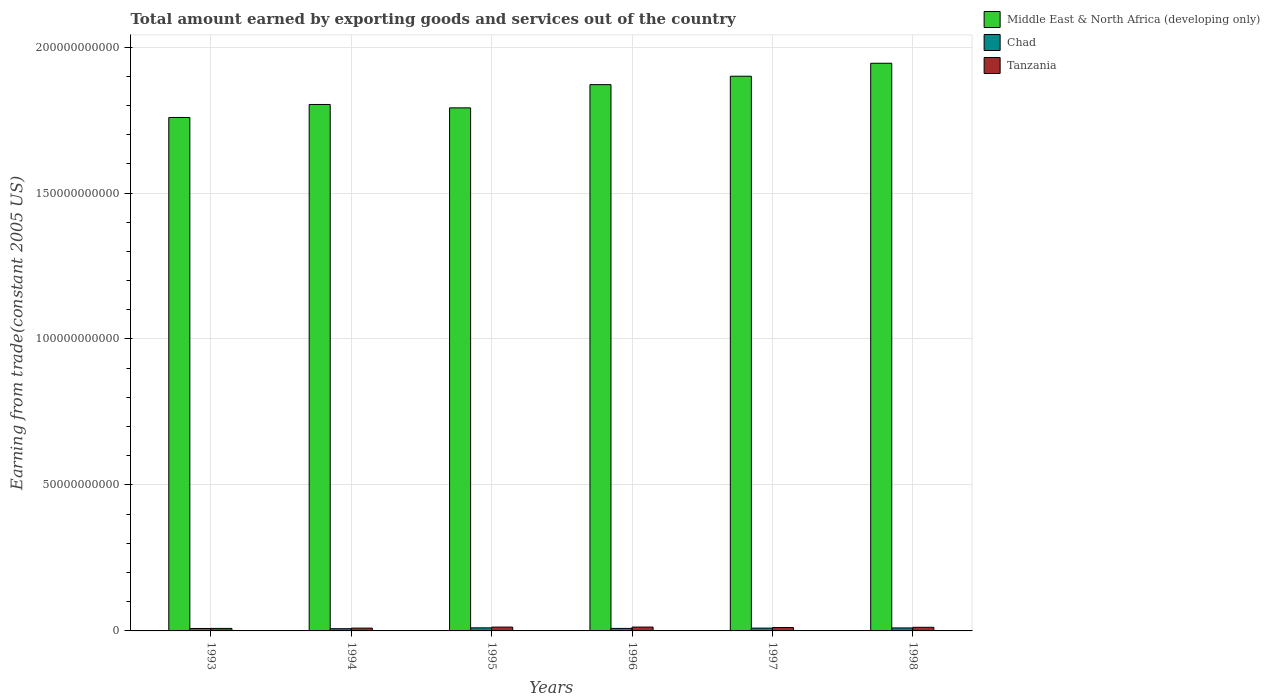Are the number of bars per tick equal to the number of legend labels?
Provide a short and direct response. Yes. How many bars are there on the 6th tick from the left?
Provide a short and direct response. 3. What is the label of the 2nd group of bars from the left?
Your response must be concise. 1994. What is the total amount earned by exporting goods and services in Chad in 1994?
Keep it short and to the point. 7.63e+08. Across all years, what is the maximum total amount earned by exporting goods and services in Middle East & North Africa (developing only)?
Your answer should be very brief. 1.94e+11. Across all years, what is the minimum total amount earned by exporting goods and services in Middle East & North Africa (developing only)?
Keep it short and to the point. 1.76e+11. What is the total total amount earned by exporting goods and services in Middle East & North Africa (developing only) in the graph?
Your answer should be very brief. 1.11e+12. What is the difference between the total amount earned by exporting goods and services in Middle East & North Africa (developing only) in 1996 and that in 1997?
Keep it short and to the point. -2.87e+09. What is the difference between the total amount earned by exporting goods and services in Tanzania in 1994 and the total amount earned by exporting goods and services in Chad in 1995?
Offer a very short reply. -9.25e+07. What is the average total amount earned by exporting goods and services in Middle East & North Africa (developing only) per year?
Keep it short and to the point. 1.85e+11. In the year 1997, what is the difference between the total amount earned by exporting goods and services in Middle East & North Africa (developing only) and total amount earned by exporting goods and services in Chad?
Offer a terse response. 1.89e+11. In how many years, is the total amount earned by exporting goods and services in Tanzania greater than 100000000000 US$?
Your response must be concise. 0. What is the ratio of the total amount earned by exporting goods and services in Middle East & North Africa (developing only) in 1994 to that in 1996?
Your answer should be compact. 0.96. Is the total amount earned by exporting goods and services in Middle East & North Africa (developing only) in 1993 less than that in 1998?
Give a very brief answer. Yes. What is the difference between the highest and the second highest total amount earned by exporting goods and services in Tanzania?
Offer a terse response. 1.37e+07. What is the difference between the highest and the lowest total amount earned by exporting goods and services in Chad?
Your answer should be very brief. 2.89e+08. What does the 3rd bar from the left in 1993 represents?
Ensure brevity in your answer.  Tanzania. What does the 1st bar from the right in 1994 represents?
Ensure brevity in your answer.  Tanzania. How many years are there in the graph?
Provide a succinct answer. 6. What is the difference between two consecutive major ticks on the Y-axis?
Keep it short and to the point. 5.00e+1. Are the values on the major ticks of Y-axis written in scientific E-notation?
Provide a succinct answer. No. Where does the legend appear in the graph?
Give a very brief answer. Top right. How many legend labels are there?
Provide a succinct answer. 3. What is the title of the graph?
Give a very brief answer. Total amount earned by exporting goods and services out of the country. What is the label or title of the X-axis?
Your answer should be compact. Years. What is the label or title of the Y-axis?
Your response must be concise. Earning from trade(constant 2005 US). What is the Earning from trade(constant 2005 US) of Middle East & North Africa (developing only) in 1993?
Your response must be concise. 1.76e+11. What is the Earning from trade(constant 2005 US) in Chad in 1993?
Offer a terse response. 8.40e+08. What is the Earning from trade(constant 2005 US) in Tanzania in 1993?
Provide a succinct answer. 8.60e+08. What is the Earning from trade(constant 2005 US) in Middle East & North Africa (developing only) in 1994?
Your response must be concise. 1.80e+11. What is the Earning from trade(constant 2005 US) in Chad in 1994?
Offer a terse response. 7.63e+08. What is the Earning from trade(constant 2005 US) of Tanzania in 1994?
Offer a terse response. 9.59e+08. What is the Earning from trade(constant 2005 US) of Middle East & North Africa (developing only) in 1995?
Ensure brevity in your answer.  1.79e+11. What is the Earning from trade(constant 2005 US) in Chad in 1995?
Your response must be concise. 1.05e+09. What is the Earning from trade(constant 2005 US) in Tanzania in 1995?
Give a very brief answer. 1.31e+09. What is the Earning from trade(constant 2005 US) in Middle East & North Africa (developing only) in 1996?
Make the answer very short. 1.87e+11. What is the Earning from trade(constant 2005 US) of Chad in 1996?
Your answer should be compact. 8.60e+08. What is the Earning from trade(constant 2005 US) in Tanzania in 1996?
Ensure brevity in your answer.  1.32e+09. What is the Earning from trade(constant 2005 US) of Middle East & North Africa (developing only) in 1997?
Provide a short and direct response. 1.90e+11. What is the Earning from trade(constant 2005 US) of Chad in 1997?
Your response must be concise. 9.61e+08. What is the Earning from trade(constant 2005 US) of Tanzania in 1997?
Offer a very short reply. 1.16e+09. What is the Earning from trade(constant 2005 US) of Middle East & North Africa (developing only) in 1998?
Your response must be concise. 1.94e+11. What is the Earning from trade(constant 2005 US) of Chad in 1998?
Keep it short and to the point. 1.02e+09. What is the Earning from trade(constant 2005 US) in Tanzania in 1998?
Your answer should be compact. 1.24e+09. Across all years, what is the maximum Earning from trade(constant 2005 US) of Middle East & North Africa (developing only)?
Provide a succinct answer. 1.94e+11. Across all years, what is the maximum Earning from trade(constant 2005 US) in Chad?
Give a very brief answer. 1.05e+09. Across all years, what is the maximum Earning from trade(constant 2005 US) in Tanzania?
Your response must be concise. 1.32e+09. Across all years, what is the minimum Earning from trade(constant 2005 US) of Middle East & North Africa (developing only)?
Offer a very short reply. 1.76e+11. Across all years, what is the minimum Earning from trade(constant 2005 US) of Chad?
Your answer should be compact. 7.63e+08. Across all years, what is the minimum Earning from trade(constant 2005 US) of Tanzania?
Ensure brevity in your answer.  8.60e+08. What is the total Earning from trade(constant 2005 US) of Middle East & North Africa (developing only) in the graph?
Provide a short and direct response. 1.11e+12. What is the total Earning from trade(constant 2005 US) in Chad in the graph?
Give a very brief answer. 5.50e+09. What is the total Earning from trade(constant 2005 US) of Tanzania in the graph?
Your answer should be compact. 6.85e+09. What is the difference between the Earning from trade(constant 2005 US) in Middle East & North Africa (developing only) in 1993 and that in 1994?
Keep it short and to the point. -4.45e+09. What is the difference between the Earning from trade(constant 2005 US) in Chad in 1993 and that in 1994?
Provide a short and direct response. 7.65e+07. What is the difference between the Earning from trade(constant 2005 US) of Tanzania in 1993 and that in 1994?
Provide a short and direct response. -9.94e+07. What is the difference between the Earning from trade(constant 2005 US) of Middle East & North Africa (developing only) in 1993 and that in 1995?
Provide a succinct answer. -3.29e+09. What is the difference between the Earning from trade(constant 2005 US) in Chad in 1993 and that in 1995?
Provide a succinct answer. -2.12e+08. What is the difference between the Earning from trade(constant 2005 US) of Tanzania in 1993 and that in 1995?
Make the answer very short. -4.48e+08. What is the difference between the Earning from trade(constant 2005 US) of Middle East & North Africa (developing only) in 1993 and that in 1996?
Make the answer very short. -1.13e+1. What is the difference between the Earning from trade(constant 2005 US) of Chad in 1993 and that in 1996?
Offer a very short reply. -2.05e+07. What is the difference between the Earning from trade(constant 2005 US) in Tanzania in 1993 and that in 1996?
Provide a short and direct response. -4.62e+08. What is the difference between the Earning from trade(constant 2005 US) in Middle East & North Africa (developing only) in 1993 and that in 1997?
Offer a very short reply. -1.41e+1. What is the difference between the Earning from trade(constant 2005 US) of Chad in 1993 and that in 1997?
Make the answer very short. -1.21e+08. What is the difference between the Earning from trade(constant 2005 US) in Tanzania in 1993 and that in 1997?
Keep it short and to the point. -3.03e+08. What is the difference between the Earning from trade(constant 2005 US) in Middle East & North Africa (developing only) in 1993 and that in 1998?
Ensure brevity in your answer.  -1.86e+1. What is the difference between the Earning from trade(constant 2005 US) of Chad in 1993 and that in 1998?
Your answer should be very brief. -1.85e+08. What is the difference between the Earning from trade(constant 2005 US) of Tanzania in 1993 and that in 1998?
Your answer should be very brief. -3.79e+08. What is the difference between the Earning from trade(constant 2005 US) of Middle East & North Africa (developing only) in 1994 and that in 1995?
Your answer should be very brief. 1.16e+09. What is the difference between the Earning from trade(constant 2005 US) in Chad in 1994 and that in 1995?
Your answer should be very brief. -2.89e+08. What is the difference between the Earning from trade(constant 2005 US) of Tanzania in 1994 and that in 1995?
Ensure brevity in your answer.  -3.49e+08. What is the difference between the Earning from trade(constant 2005 US) in Middle East & North Africa (developing only) in 1994 and that in 1996?
Give a very brief answer. -6.81e+09. What is the difference between the Earning from trade(constant 2005 US) of Chad in 1994 and that in 1996?
Ensure brevity in your answer.  -9.70e+07. What is the difference between the Earning from trade(constant 2005 US) of Tanzania in 1994 and that in 1996?
Provide a succinct answer. -3.62e+08. What is the difference between the Earning from trade(constant 2005 US) in Middle East & North Africa (developing only) in 1994 and that in 1997?
Your answer should be compact. -9.68e+09. What is the difference between the Earning from trade(constant 2005 US) in Chad in 1994 and that in 1997?
Offer a very short reply. -1.97e+08. What is the difference between the Earning from trade(constant 2005 US) in Tanzania in 1994 and that in 1997?
Ensure brevity in your answer.  -2.04e+08. What is the difference between the Earning from trade(constant 2005 US) in Middle East & North Africa (developing only) in 1994 and that in 1998?
Offer a terse response. -1.41e+1. What is the difference between the Earning from trade(constant 2005 US) in Chad in 1994 and that in 1998?
Provide a succinct answer. -2.61e+08. What is the difference between the Earning from trade(constant 2005 US) in Tanzania in 1994 and that in 1998?
Keep it short and to the point. -2.79e+08. What is the difference between the Earning from trade(constant 2005 US) of Middle East & North Africa (developing only) in 1995 and that in 1996?
Your answer should be very brief. -7.96e+09. What is the difference between the Earning from trade(constant 2005 US) in Chad in 1995 and that in 1996?
Give a very brief answer. 1.92e+08. What is the difference between the Earning from trade(constant 2005 US) in Tanzania in 1995 and that in 1996?
Keep it short and to the point. -1.37e+07. What is the difference between the Earning from trade(constant 2005 US) in Middle East & North Africa (developing only) in 1995 and that in 1997?
Your answer should be compact. -1.08e+1. What is the difference between the Earning from trade(constant 2005 US) in Chad in 1995 and that in 1997?
Your answer should be compact. 9.13e+07. What is the difference between the Earning from trade(constant 2005 US) in Tanzania in 1995 and that in 1997?
Offer a very short reply. 1.45e+08. What is the difference between the Earning from trade(constant 2005 US) in Middle East & North Africa (developing only) in 1995 and that in 1998?
Offer a very short reply. -1.53e+1. What is the difference between the Earning from trade(constant 2005 US) in Chad in 1995 and that in 1998?
Provide a short and direct response. 2.74e+07. What is the difference between the Earning from trade(constant 2005 US) in Tanzania in 1995 and that in 1998?
Your response must be concise. 6.93e+07. What is the difference between the Earning from trade(constant 2005 US) in Middle East & North Africa (developing only) in 1996 and that in 1997?
Make the answer very short. -2.87e+09. What is the difference between the Earning from trade(constant 2005 US) of Chad in 1996 and that in 1997?
Your answer should be very brief. -1.00e+08. What is the difference between the Earning from trade(constant 2005 US) in Tanzania in 1996 and that in 1997?
Provide a short and direct response. 1.58e+08. What is the difference between the Earning from trade(constant 2005 US) of Middle East & North Africa (developing only) in 1996 and that in 1998?
Make the answer very short. -7.32e+09. What is the difference between the Earning from trade(constant 2005 US) in Chad in 1996 and that in 1998?
Give a very brief answer. -1.64e+08. What is the difference between the Earning from trade(constant 2005 US) of Tanzania in 1996 and that in 1998?
Make the answer very short. 8.30e+07. What is the difference between the Earning from trade(constant 2005 US) in Middle East & North Africa (developing only) in 1997 and that in 1998?
Give a very brief answer. -4.44e+09. What is the difference between the Earning from trade(constant 2005 US) of Chad in 1997 and that in 1998?
Your response must be concise. -6.39e+07. What is the difference between the Earning from trade(constant 2005 US) in Tanzania in 1997 and that in 1998?
Your response must be concise. -7.54e+07. What is the difference between the Earning from trade(constant 2005 US) in Middle East & North Africa (developing only) in 1993 and the Earning from trade(constant 2005 US) in Chad in 1994?
Give a very brief answer. 1.75e+11. What is the difference between the Earning from trade(constant 2005 US) in Middle East & North Africa (developing only) in 1993 and the Earning from trade(constant 2005 US) in Tanzania in 1994?
Provide a succinct answer. 1.75e+11. What is the difference between the Earning from trade(constant 2005 US) of Chad in 1993 and the Earning from trade(constant 2005 US) of Tanzania in 1994?
Your response must be concise. -1.20e+08. What is the difference between the Earning from trade(constant 2005 US) in Middle East & North Africa (developing only) in 1993 and the Earning from trade(constant 2005 US) in Chad in 1995?
Make the answer very short. 1.75e+11. What is the difference between the Earning from trade(constant 2005 US) of Middle East & North Africa (developing only) in 1993 and the Earning from trade(constant 2005 US) of Tanzania in 1995?
Give a very brief answer. 1.75e+11. What is the difference between the Earning from trade(constant 2005 US) of Chad in 1993 and the Earning from trade(constant 2005 US) of Tanzania in 1995?
Offer a terse response. -4.68e+08. What is the difference between the Earning from trade(constant 2005 US) in Middle East & North Africa (developing only) in 1993 and the Earning from trade(constant 2005 US) in Chad in 1996?
Ensure brevity in your answer.  1.75e+11. What is the difference between the Earning from trade(constant 2005 US) of Middle East & North Africa (developing only) in 1993 and the Earning from trade(constant 2005 US) of Tanzania in 1996?
Offer a terse response. 1.75e+11. What is the difference between the Earning from trade(constant 2005 US) of Chad in 1993 and the Earning from trade(constant 2005 US) of Tanzania in 1996?
Your answer should be very brief. -4.82e+08. What is the difference between the Earning from trade(constant 2005 US) in Middle East & North Africa (developing only) in 1993 and the Earning from trade(constant 2005 US) in Chad in 1997?
Make the answer very short. 1.75e+11. What is the difference between the Earning from trade(constant 2005 US) in Middle East & North Africa (developing only) in 1993 and the Earning from trade(constant 2005 US) in Tanzania in 1997?
Give a very brief answer. 1.75e+11. What is the difference between the Earning from trade(constant 2005 US) of Chad in 1993 and the Earning from trade(constant 2005 US) of Tanzania in 1997?
Keep it short and to the point. -3.24e+08. What is the difference between the Earning from trade(constant 2005 US) of Middle East & North Africa (developing only) in 1993 and the Earning from trade(constant 2005 US) of Chad in 1998?
Give a very brief answer. 1.75e+11. What is the difference between the Earning from trade(constant 2005 US) of Middle East & North Africa (developing only) in 1993 and the Earning from trade(constant 2005 US) of Tanzania in 1998?
Ensure brevity in your answer.  1.75e+11. What is the difference between the Earning from trade(constant 2005 US) in Chad in 1993 and the Earning from trade(constant 2005 US) in Tanzania in 1998?
Provide a succinct answer. -3.99e+08. What is the difference between the Earning from trade(constant 2005 US) of Middle East & North Africa (developing only) in 1994 and the Earning from trade(constant 2005 US) of Chad in 1995?
Ensure brevity in your answer.  1.79e+11. What is the difference between the Earning from trade(constant 2005 US) of Middle East & North Africa (developing only) in 1994 and the Earning from trade(constant 2005 US) of Tanzania in 1995?
Your answer should be compact. 1.79e+11. What is the difference between the Earning from trade(constant 2005 US) in Chad in 1994 and the Earning from trade(constant 2005 US) in Tanzania in 1995?
Provide a succinct answer. -5.45e+08. What is the difference between the Earning from trade(constant 2005 US) of Middle East & North Africa (developing only) in 1994 and the Earning from trade(constant 2005 US) of Chad in 1996?
Keep it short and to the point. 1.79e+11. What is the difference between the Earning from trade(constant 2005 US) in Middle East & North Africa (developing only) in 1994 and the Earning from trade(constant 2005 US) in Tanzania in 1996?
Offer a very short reply. 1.79e+11. What is the difference between the Earning from trade(constant 2005 US) in Chad in 1994 and the Earning from trade(constant 2005 US) in Tanzania in 1996?
Your response must be concise. -5.59e+08. What is the difference between the Earning from trade(constant 2005 US) in Middle East & North Africa (developing only) in 1994 and the Earning from trade(constant 2005 US) in Chad in 1997?
Make the answer very short. 1.79e+11. What is the difference between the Earning from trade(constant 2005 US) in Middle East & North Africa (developing only) in 1994 and the Earning from trade(constant 2005 US) in Tanzania in 1997?
Your response must be concise. 1.79e+11. What is the difference between the Earning from trade(constant 2005 US) of Chad in 1994 and the Earning from trade(constant 2005 US) of Tanzania in 1997?
Give a very brief answer. -4.00e+08. What is the difference between the Earning from trade(constant 2005 US) of Middle East & North Africa (developing only) in 1994 and the Earning from trade(constant 2005 US) of Chad in 1998?
Give a very brief answer. 1.79e+11. What is the difference between the Earning from trade(constant 2005 US) in Middle East & North Africa (developing only) in 1994 and the Earning from trade(constant 2005 US) in Tanzania in 1998?
Your answer should be very brief. 1.79e+11. What is the difference between the Earning from trade(constant 2005 US) in Chad in 1994 and the Earning from trade(constant 2005 US) in Tanzania in 1998?
Offer a terse response. -4.76e+08. What is the difference between the Earning from trade(constant 2005 US) of Middle East & North Africa (developing only) in 1995 and the Earning from trade(constant 2005 US) of Chad in 1996?
Your answer should be very brief. 1.78e+11. What is the difference between the Earning from trade(constant 2005 US) of Middle East & North Africa (developing only) in 1995 and the Earning from trade(constant 2005 US) of Tanzania in 1996?
Provide a short and direct response. 1.78e+11. What is the difference between the Earning from trade(constant 2005 US) of Chad in 1995 and the Earning from trade(constant 2005 US) of Tanzania in 1996?
Keep it short and to the point. -2.70e+08. What is the difference between the Earning from trade(constant 2005 US) of Middle East & North Africa (developing only) in 1995 and the Earning from trade(constant 2005 US) of Chad in 1997?
Keep it short and to the point. 1.78e+11. What is the difference between the Earning from trade(constant 2005 US) of Middle East & North Africa (developing only) in 1995 and the Earning from trade(constant 2005 US) of Tanzania in 1997?
Give a very brief answer. 1.78e+11. What is the difference between the Earning from trade(constant 2005 US) of Chad in 1995 and the Earning from trade(constant 2005 US) of Tanzania in 1997?
Keep it short and to the point. -1.11e+08. What is the difference between the Earning from trade(constant 2005 US) in Middle East & North Africa (developing only) in 1995 and the Earning from trade(constant 2005 US) in Chad in 1998?
Offer a very short reply. 1.78e+11. What is the difference between the Earning from trade(constant 2005 US) in Middle East & North Africa (developing only) in 1995 and the Earning from trade(constant 2005 US) in Tanzania in 1998?
Give a very brief answer. 1.78e+11. What is the difference between the Earning from trade(constant 2005 US) in Chad in 1995 and the Earning from trade(constant 2005 US) in Tanzania in 1998?
Your answer should be compact. -1.87e+08. What is the difference between the Earning from trade(constant 2005 US) in Middle East & North Africa (developing only) in 1996 and the Earning from trade(constant 2005 US) in Chad in 1997?
Make the answer very short. 1.86e+11. What is the difference between the Earning from trade(constant 2005 US) in Middle East & North Africa (developing only) in 1996 and the Earning from trade(constant 2005 US) in Tanzania in 1997?
Your answer should be compact. 1.86e+11. What is the difference between the Earning from trade(constant 2005 US) of Chad in 1996 and the Earning from trade(constant 2005 US) of Tanzania in 1997?
Ensure brevity in your answer.  -3.03e+08. What is the difference between the Earning from trade(constant 2005 US) of Middle East & North Africa (developing only) in 1996 and the Earning from trade(constant 2005 US) of Chad in 1998?
Your answer should be compact. 1.86e+11. What is the difference between the Earning from trade(constant 2005 US) in Middle East & North Africa (developing only) in 1996 and the Earning from trade(constant 2005 US) in Tanzania in 1998?
Provide a short and direct response. 1.86e+11. What is the difference between the Earning from trade(constant 2005 US) of Chad in 1996 and the Earning from trade(constant 2005 US) of Tanzania in 1998?
Provide a short and direct response. -3.79e+08. What is the difference between the Earning from trade(constant 2005 US) in Middle East & North Africa (developing only) in 1997 and the Earning from trade(constant 2005 US) in Chad in 1998?
Offer a very short reply. 1.89e+11. What is the difference between the Earning from trade(constant 2005 US) of Middle East & North Africa (developing only) in 1997 and the Earning from trade(constant 2005 US) of Tanzania in 1998?
Provide a short and direct response. 1.89e+11. What is the difference between the Earning from trade(constant 2005 US) in Chad in 1997 and the Earning from trade(constant 2005 US) in Tanzania in 1998?
Your answer should be compact. -2.78e+08. What is the average Earning from trade(constant 2005 US) of Middle East & North Africa (developing only) per year?
Keep it short and to the point. 1.85e+11. What is the average Earning from trade(constant 2005 US) of Chad per year?
Keep it short and to the point. 9.17e+08. What is the average Earning from trade(constant 2005 US) in Tanzania per year?
Offer a very short reply. 1.14e+09. In the year 1993, what is the difference between the Earning from trade(constant 2005 US) in Middle East & North Africa (developing only) and Earning from trade(constant 2005 US) in Chad?
Offer a very short reply. 1.75e+11. In the year 1993, what is the difference between the Earning from trade(constant 2005 US) in Middle East & North Africa (developing only) and Earning from trade(constant 2005 US) in Tanzania?
Ensure brevity in your answer.  1.75e+11. In the year 1993, what is the difference between the Earning from trade(constant 2005 US) in Chad and Earning from trade(constant 2005 US) in Tanzania?
Provide a succinct answer. -2.04e+07. In the year 1994, what is the difference between the Earning from trade(constant 2005 US) of Middle East & North Africa (developing only) and Earning from trade(constant 2005 US) of Chad?
Offer a terse response. 1.80e+11. In the year 1994, what is the difference between the Earning from trade(constant 2005 US) of Middle East & North Africa (developing only) and Earning from trade(constant 2005 US) of Tanzania?
Your answer should be compact. 1.79e+11. In the year 1994, what is the difference between the Earning from trade(constant 2005 US) of Chad and Earning from trade(constant 2005 US) of Tanzania?
Give a very brief answer. -1.96e+08. In the year 1995, what is the difference between the Earning from trade(constant 2005 US) in Middle East & North Africa (developing only) and Earning from trade(constant 2005 US) in Chad?
Your answer should be compact. 1.78e+11. In the year 1995, what is the difference between the Earning from trade(constant 2005 US) in Middle East & North Africa (developing only) and Earning from trade(constant 2005 US) in Tanzania?
Offer a terse response. 1.78e+11. In the year 1995, what is the difference between the Earning from trade(constant 2005 US) in Chad and Earning from trade(constant 2005 US) in Tanzania?
Provide a succinct answer. -2.56e+08. In the year 1996, what is the difference between the Earning from trade(constant 2005 US) in Middle East & North Africa (developing only) and Earning from trade(constant 2005 US) in Chad?
Your response must be concise. 1.86e+11. In the year 1996, what is the difference between the Earning from trade(constant 2005 US) in Middle East & North Africa (developing only) and Earning from trade(constant 2005 US) in Tanzania?
Provide a short and direct response. 1.86e+11. In the year 1996, what is the difference between the Earning from trade(constant 2005 US) of Chad and Earning from trade(constant 2005 US) of Tanzania?
Give a very brief answer. -4.62e+08. In the year 1997, what is the difference between the Earning from trade(constant 2005 US) of Middle East & North Africa (developing only) and Earning from trade(constant 2005 US) of Chad?
Keep it short and to the point. 1.89e+11. In the year 1997, what is the difference between the Earning from trade(constant 2005 US) of Middle East & North Africa (developing only) and Earning from trade(constant 2005 US) of Tanzania?
Offer a terse response. 1.89e+11. In the year 1997, what is the difference between the Earning from trade(constant 2005 US) in Chad and Earning from trade(constant 2005 US) in Tanzania?
Your answer should be compact. -2.03e+08. In the year 1998, what is the difference between the Earning from trade(constant 2005 US) in Middle East & North Africa (developing only) and Earning from trade(constant 2005 US) in Chad?
Offer a terse response. 1.93e+11. In the year 1998, what is the difference between the Earning from trade(constant 2005 US) in Middle East & North Africa (developing only) and Earning from trade(constant 2005 US) in Tanzania?
Offer a very short reply. 1.93e+11. In the year 1998, what is the difference between the Earning from trade(constant 2005 US) in Chad and Earning from trade(constant 2005 US) in Tanzania?
Your response must be concise. -2.14e+08. What is the ratio of the Earning from trade(constant 2005 US) of Middle East & North Africa (developing only) in 1993 to that in 1994?
Your answer should be very brief. 0.98. What is the ratio of the Earning from trade(constant 2005 US) of Chad in 1993 to that in 1994?
Give a very brief answer. 1.1. What is the ratio of the Earning from trade(constant 2005 US) in Tanzania in 1993 to that in 1994?
Your answer should be very brief. 0.9. What is the ratio of the Earning from trade(constant 2005 US) of Middle East & North Africa (developing only) in 1993 to that in 1995?
Your answer should be very brief. 0.98. What is the ratio of the Earning from trade(constant 2005 US) in Chad in 1993 to that in 1995?
Give a very brief answer. 0.8. What is the ratio of the Earning from trade(constant 2005 US) of Tanzania in 1993 to that in 1995?
Make the answer very short. 0.66. What is the ratio of the Earning from trade(constant 2005 US) in Middle East & North Africa (developing only) in 1993 to that in 1996?
Provide a succinct answer. 0.94. What is the ratio of the Earning from trade(constant 2005 US) of Chad in 1993 to that in 1996?
Give a very brief answer. 0.98. What is the ratio of the Earning from trade(constant 2005 US) in Tanzania in 1993 to that in 1996?
Make the answer very short. 0.65. What is the ratio of the Earning from trade(constant 2005 US) in Middle East & North Africa (developing only) in 1993 to that in 1997?
Give a very brief answer. 0.93. What is the ratio of the Earning from trade(constant 2005 US) in Chad in 1993 to that in 1997?
Offer a terse response. 0.87. What is the ratio of the Earning from trade(constant 2005 US) of Tanzania in 1993 to that in 1997?
Offer a very short reply. 0.74. What is the ratio of the Earning from trade(constant 2005 US) in Middle East & North Africa (developing only) in 1993 to that in 1998?
Make the answer very short. 0.9. What is the ratio of the Earning from trade(constant 2005 US) in Chad in 1993 to that in 1998?
Your answer should be compact. 0.82. What is the ratio of the Earning from trade(constant 2005 US) in Tanzania in 1993 to that in 1998?
Provide a succinct answer. 0.69. What is the ratio of the Earning from trade(constant 2005 US) of Middle East & North Africa (developing only) in 1994 to that in 1995?
Provide a succinct answer. 1.01. What is the ratio of the Earning from trade(constant 2005 US) in Chad in 1994 to that in 1995?
Offer a very short reply. 0.73. What is the ratio of the Earning from trade(constant 2005 US) in Tanzania in 1994 to that in 1995?
Provide a short and direct response. 0.73. What is the ratio of the Earning from trade(constant 2005 US) in Middle East & North Africa (developing only) in 1994 to that in 1996?
Offer a very short reply. 0.96. What is the ratio of the Earning from trade(constant 2005 US) of Chad in 1994 to that in 1996?
Ensure brevity in your answer.  0.89. What is the ratio of the Earning from trade(constant 2005 US) in Tanzania in 1994 to that in 1996?
Your answer should be very brief. 0.73. What is the ratio of the Earning from trade(constant 2005 US) in Middle East & North Africa (developing only) in 1994 to that in 1997?
Make the answer very short. 0.95. What is the ratio of the Earning from trade(constant 2005 US) of Chad in 1994 to that in 1997?
Provide a succinct answer. 0.79. What is the ratio of the Earning from trade(constant 2005 US) in Tanzania in 1994 to that in 1997?
Give a very brief answer. 0.82. What is the ratio of the Earning from trade(constant 2005 US) of Middle East & North Africa (developing only) in 1994 to that in 1998?
Keep it short and to the point. 0.93. What is the ratio of the Earning from trade(constant 2005 US) in Chad in 1994 to that in 1998?
Keep it short and to the point. 0.74. What is the ratio of the Earning from trade(constant 2005 US) in Tanzania in 1994 to that in 1998?
Keep it short and to the point. 0.77. What is the ratio of the Earning from trade(constant 2005 US) of Middle East & North Africa (developing only) in 1995 to that in 1996?
Provide a short and direct response. 0.96. What is the ratio of the Earning from trade(constant 2005 US) in Chad in 1995 to that in 1996?
Provide a succinct answer. 1.22. What is the ratio of the Earning from trade(constant 2005 US) in Tanzania in 1995 to that in 1996?
Your answer should be very brief. 0.99. What is the ratio of the Earning from trade(constant 2005 US) of Middle East & North Africa (developing only) in 1995 to that in 1997?
Provide a succinct answer. 0.94. What is the ratio of the Earning from trade(constant 2005 US) of Chad in 1995 to that in 1997?
Keep it short and to the point. 1.09. What is the ratio of the Earning from trade(constant 2005 US) of Tanzania in 1995 to that in 1997?
Your response must be concise. 1.12. What is the ratio of the Earning from trade(constant 2005 US) in Middle East & North Africa (developing only) in 1995 to that in 1998?
Make the answer very short. 0.92. What is the ratio of the Earning from trade(constant 2005 US) of Chad in 1995 to that in 1998?
Your answer should be compact. 1.03. What is the ratio of the Earning from trade(constant 2005 US) in Tanzania in 1995 to that in 1998?
Offer a terse response. 1.06. What is the ratio of the Earning from trade(constant 2005 US) of Middle East & North Africa (developing only) in 1996 to that in 1997?
Your answer should be compact. 0.98. What is the ratio of the Earning from trade(constant 2005 US) of Chad in 1996 to that in 1997?
Ensure brevity in your answer.  0.9. What is the ratio of the Earning from trade(constant 2005 US) of Tanzania in 1996 to that in 1997?
Keep it short and to the point. 1.14. What is the ratio of the Earning from trade(constant 2005 US) of Middle East & North Africa (developing only) in 1996 to that in 1998?
Ensure brevity in your answer.  0.96. What is the ratio of the Earning from trade(constant 2005 US) of Chad in 1996 to that in 1998?
Provide a succinct answer. 0.84. What is the ratio of the Earning from trade(constant 2005 US) in Tanzania in 1996 to that in 1998?
Make the answer very short. 1.07. What is the ratio of the Earning from trade(constant 2005 US) in Middle East & North Africa (developing only) in 1997 to that in 1998?
Your answer should be compact. 0.98. What is the ratio of the Earning from trade(constant 2005 US) of Chad in 1997 to that in 1998?
Give a very brief answer. 0.94. What is the ratio of the Earning from trade(constant 2005 US) in Tanzania in 1997 to that in 1998?
Provide a short and direct response. 0.94. What is the difference between the highest and the second highest Earning from trade(constant 2005 US) in Middle East & North Africa (developing only)?
Your response must be concise. 4.44e+09. What is the difference between the highest and the second highest Earning from trade(constant 2005 US) in Chad?
Keep it short and to the point. 2.74e+07. What is the difference between the highest and the second highest Earning from trade(constant 2005 US) in Tanzania?
Your response must be concise. 1.37e+07. What is the difference between the highest and the lowest Earning from trade(constant 2005 US) in Middle East & North Africa (developing only)?
Make the answer very short. 1.86e+1. What is the difference between the highest and the lowest Earning from trade(constant 2005 US) of Chad?
Keep it short and to the point. 2.89e+08. What is the difference between the highest and the lowest Earning from trade(constant 2005 US) of Tanzania?
Offer a very short reply. 4.62e+08. 